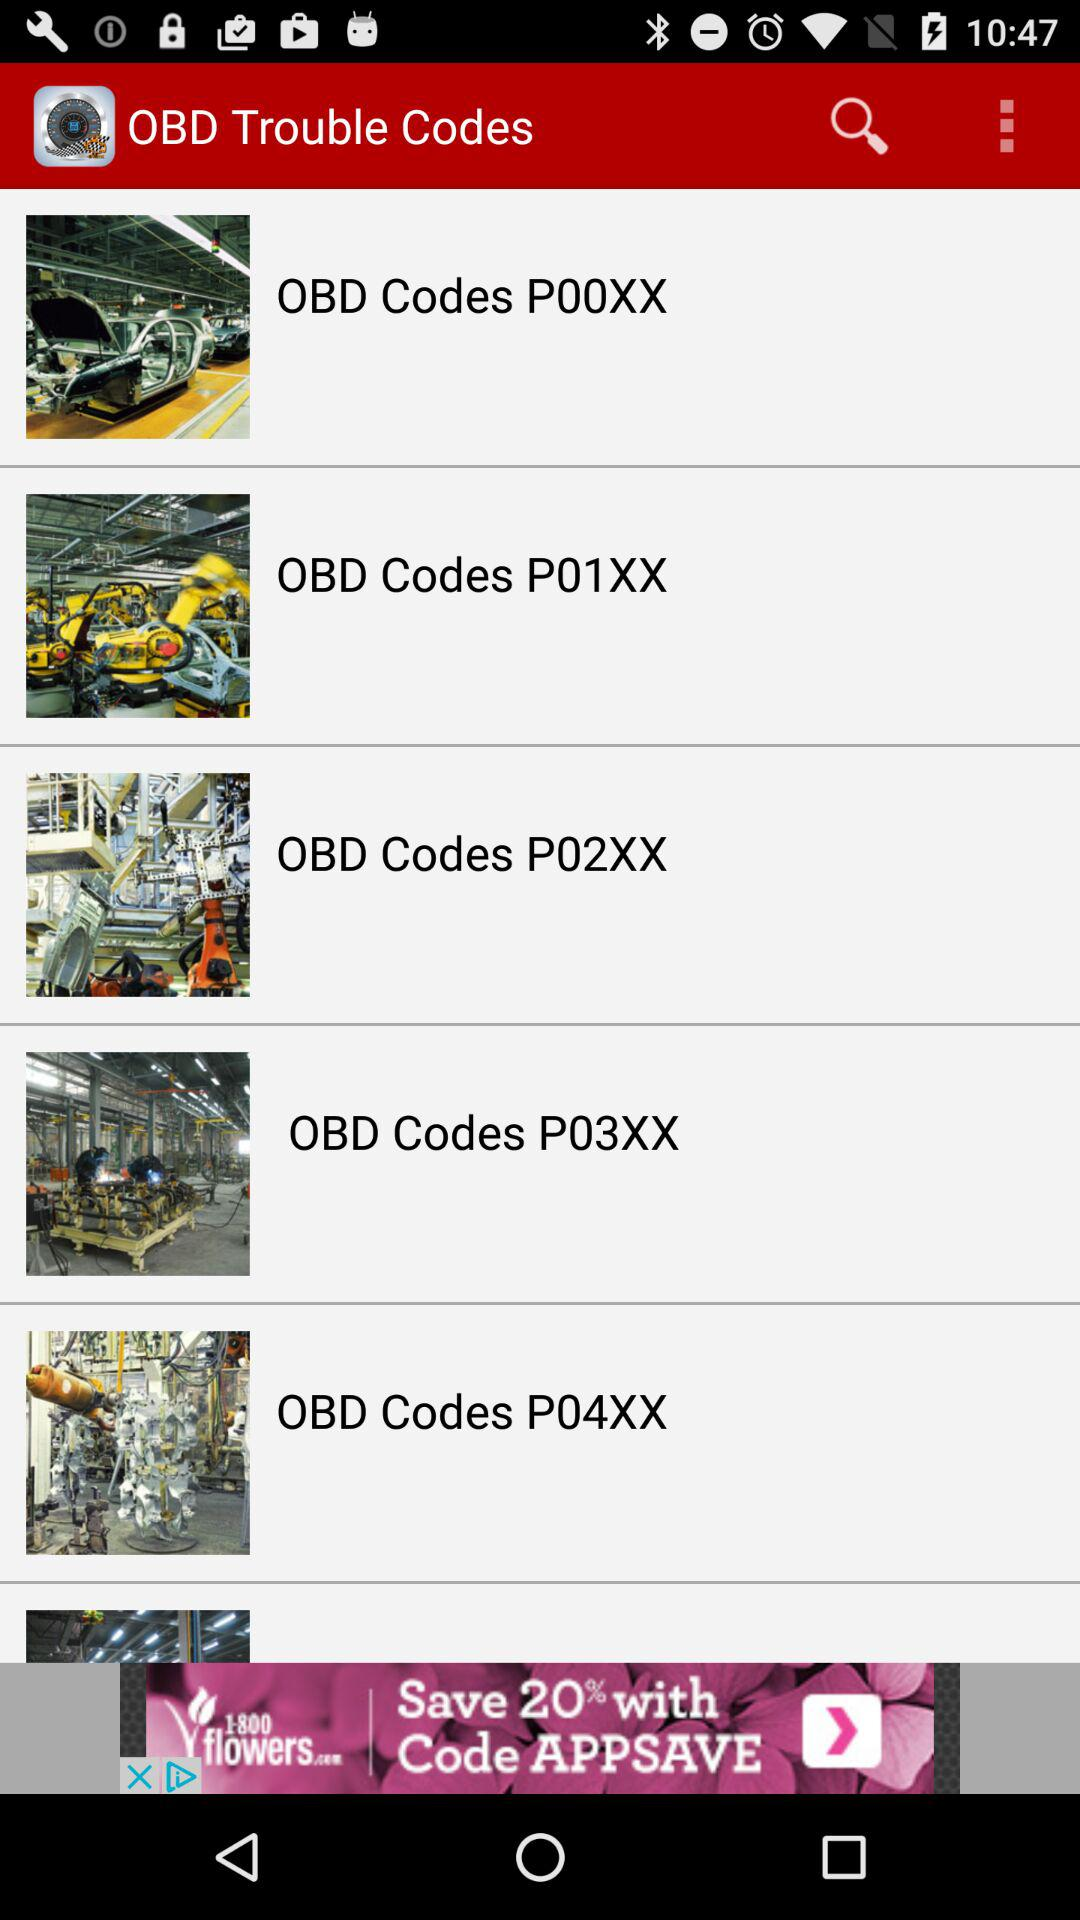What are the names of OBD Trouble Codes? The names of OBD Trouble Codes are "OBD Codes P00XX", "OBD Codes P01XX", "OBD Codes P02XX", "OBD Codes P03XX" and "OBD Codes P04XX". 